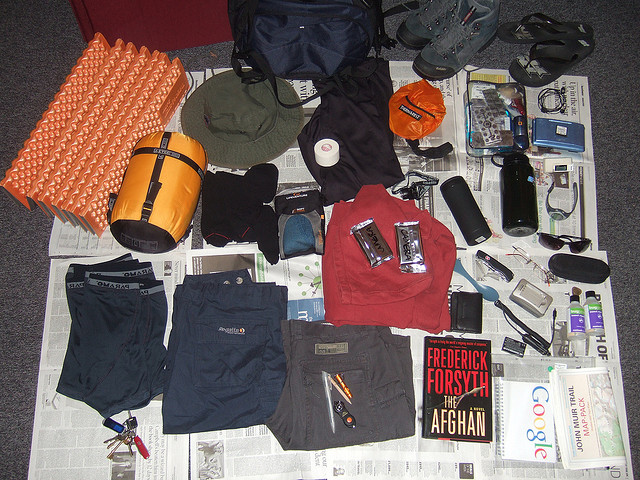Identify the text contained in this image. H JOHN MUIR TRAIL Google AFGHAN FORSYTH 